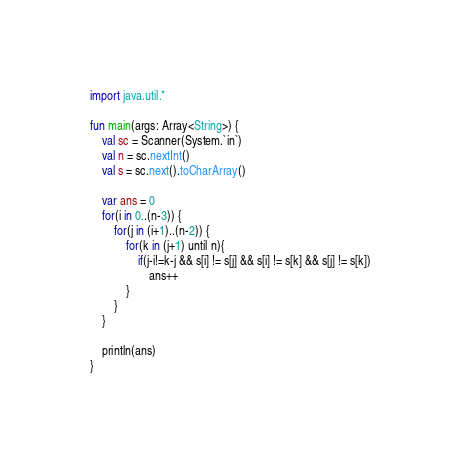Convert code to text. <code><loc_0><loc_0><loc_500><loc_500><_Kotlin_>import java.util.*

fun main(args: Array<String>) {
    val sc = Scanner(System.`in`)
    val n = sc.nextInt()
    val s = sc.next().toCharArray()

    var ans = 0
    for(i in 0..(n-3)) {
        for(j in (i+1)..(n-2)) {
            for(k in (j+1) until n){
                if(j-i!=k-j && s[i] != s[j] && s[i] != s[k] && s[j] != s[k])
                    ans++
            }
        }
    }

    println(ans)
}</code> 